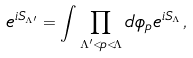<formula> <loc_0><loc_0><loc_500><loc_500>e ^ { i S _ { \Lambda ^ { \prime } } } = \int \prod _ { \Lambda ^ { \prime } < p < \Lambda } d \phi _ { p } e ^ { i S _ { \Lambda } } \, ,</formula> 